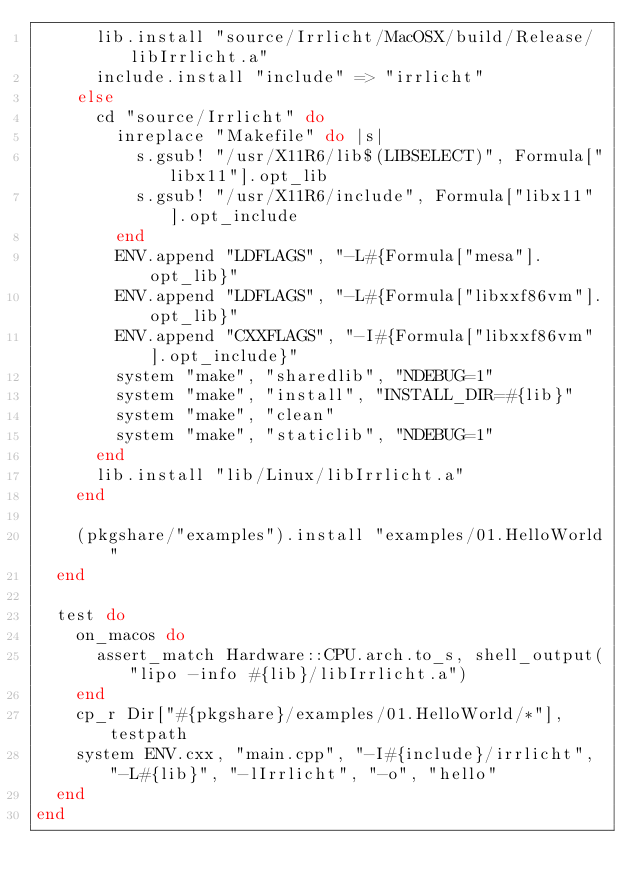Convert code to text. <code><loc_0><loc_0><loc_500><loc_500><_Ruby_>      lib.install "source/Irrlicht/MacOSX/build/Release/libIrrlicht.a"
      include.install "include" => "irrlicht"
    else
      cd "source/Irrlicht" do
        inreplace "Makefile" do |s|
          s.gsub! "/usr/X11R6/lib$(LIBSELECT)", Formula["libx11"].opt_lib
          s.gsub! "/usr/X11R6/include", Formula["libx11"].opt_include
        end
        ENV.append "LDFLAGS", "-L#{Formula["mesa"].opt_lib}"
        ENV.append "LDFLAGS", "-L#{Formula["libxxf86vm"].opt_lib}"
        ENV.append "CXXFLAGS", "-I#{Formula["libxxf86vm"].opt_include}"
        system "make", "sharedlib", "NDEBUG=1"
        system "make", "install", "INSTALL_DIR=#{lib}"
        system "make", "clean"
        system "make", "staticlib", "NDEBUG=1"
      end
      lib.install "lib/Linux/libIrrlicht.a"
    end

    (pkgshare/"examples").install "examples/01.HelloWorld"
  end

  test do
    on_macos do
      assert_match Hardware::CPU.arch.to_s, shell_output("lipo -info #{lib}/libIrrlicht.a")
    end
    cp_r Dir["#{pkgshare}/examples/01.HelloWorld/*"], testpath
    system ENV.cxx, "main.cpp", "-I#{include}/irrlicht", "-L#{lib}", "-lIrrlicht", "-o", "hello"
  end
end
</code> 